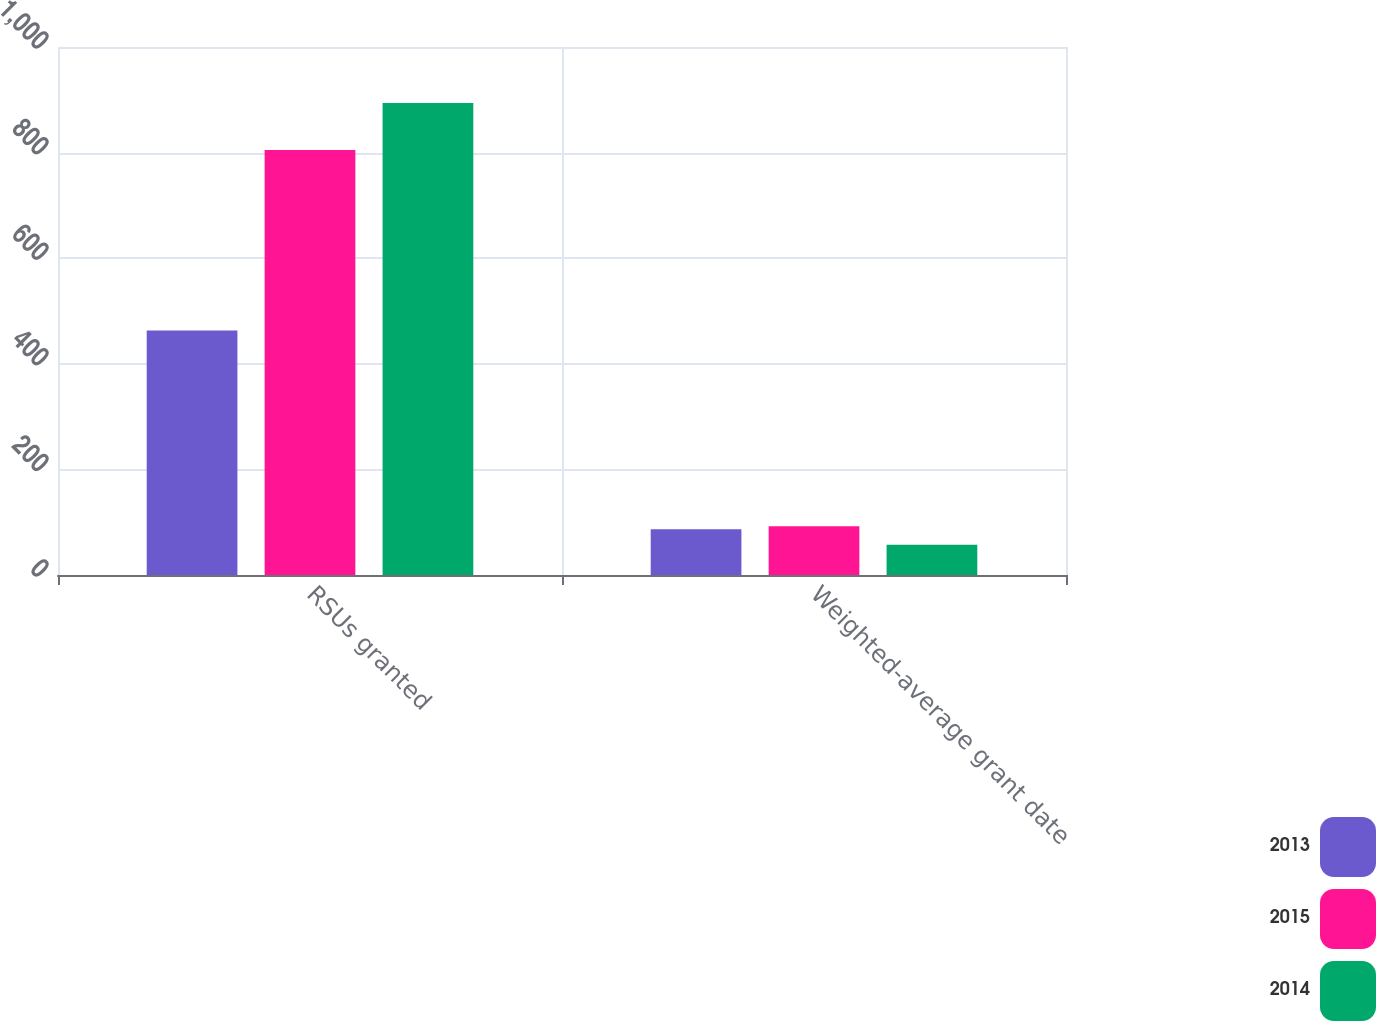Convert chart. <chart><loc_0><loc_0><loc_500><loc_500><stacked_bar_chart><ecel><fcel>RSUs granted<fcel>Weighted-average grant date<nl><fcel>2013<fcel>463<fcel>86.84<nl><fcel>2015<fcel>805<fcel>92.28<nl><fcel>2014<fcel>894<fcel>57.5<nl></chart> 